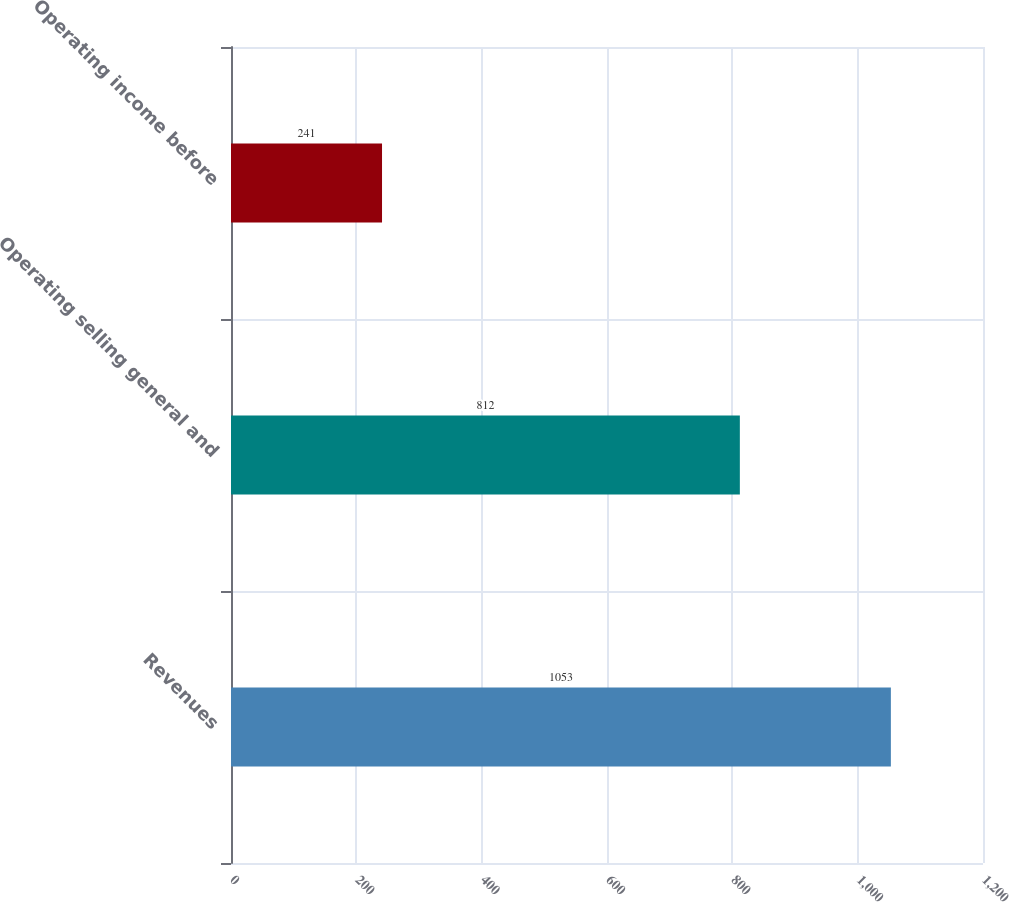<chart> <loc_0><loc_0><loc_500><loc_500><bar_chart><fcel>Revenues<fcel>Operating selling general and<fcel>Operating income before<nl><fcel>1053<fcel>812<fcel>241<nl></chart> 